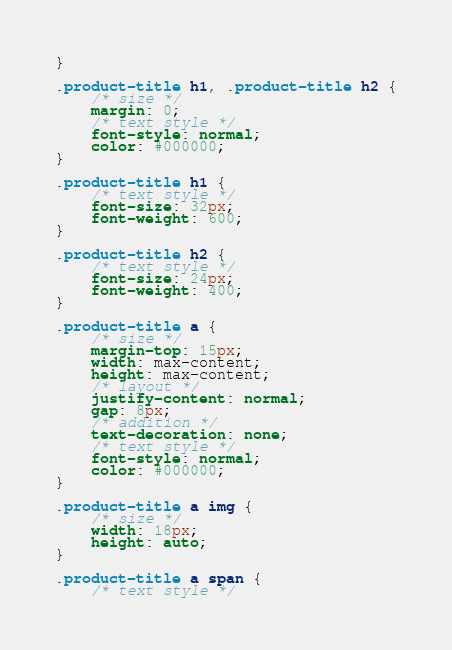Convert code to text. <code><loc_0><loc_0><loc_500><loc_500><_CSS_>}

.product-title h1, .product-title h2 {
    /* size */
    margin: 0;
    /* text style */
    font-style: normal;
    color: #000000;
}

.product-title h1 {
    /* text style */
    font-size: 32px;
    font-weight: 600;
}

.product-title h2 {
    /* text style */
    font-size: 24px;
    font-weight: 400;
}

.product-title a {
    /* size */
    margin-top: 15px;
    width: max-content;
    height: max-content;
    /* layout */
    justify-content: normal;
    gap: 8px;
    /* addition */
    text-decoration: none;
    /* text style */
    font-style: normal;
    color: #000000;
}

.product-title a img {
    /* size */
    width: 18px;
    height: auto;
}

.product-title a span {
    /* text style */</code> 